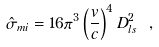<formula> <loc_0><loc_0><loc_500><loc_500>\hat { \sigma } _ { m i } = 1 6 \pi ^ { 3 } \left ( \frac { v } { c } \right ) ^ { 4 } D _ { l s } ^ { 2 } \ ,</formula> 